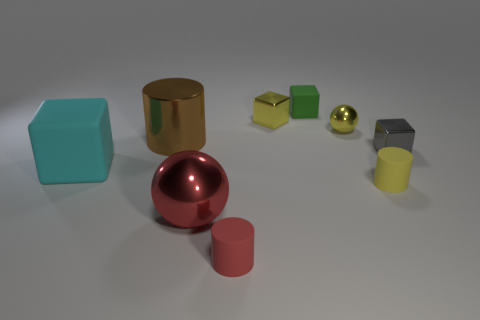Subtract all large cyan rubber cubes. How many cubes are left? 3 Subtract all red cylinders. How many cylinders are left? 2 Subtract all spheres. How many objects are left? 7 Subtract 0 green balls. How many objects are left? 9 Subtract 2 balls. How many balls are left? 0 Subtract all gray cylinders. Subtract all purple cubes. How many cylinders are left? 3 Subtract all gray balls. How many yellow cylinders are left? 1 Subtract all big purple objects. Subtract all red rubber things. How many objects are left? 8 Add 4 red matte objects. How many red matte objects are left? 5 Add 8 tiny purple shiny spheres. How many tiny purple shiny spheres exist? 8 